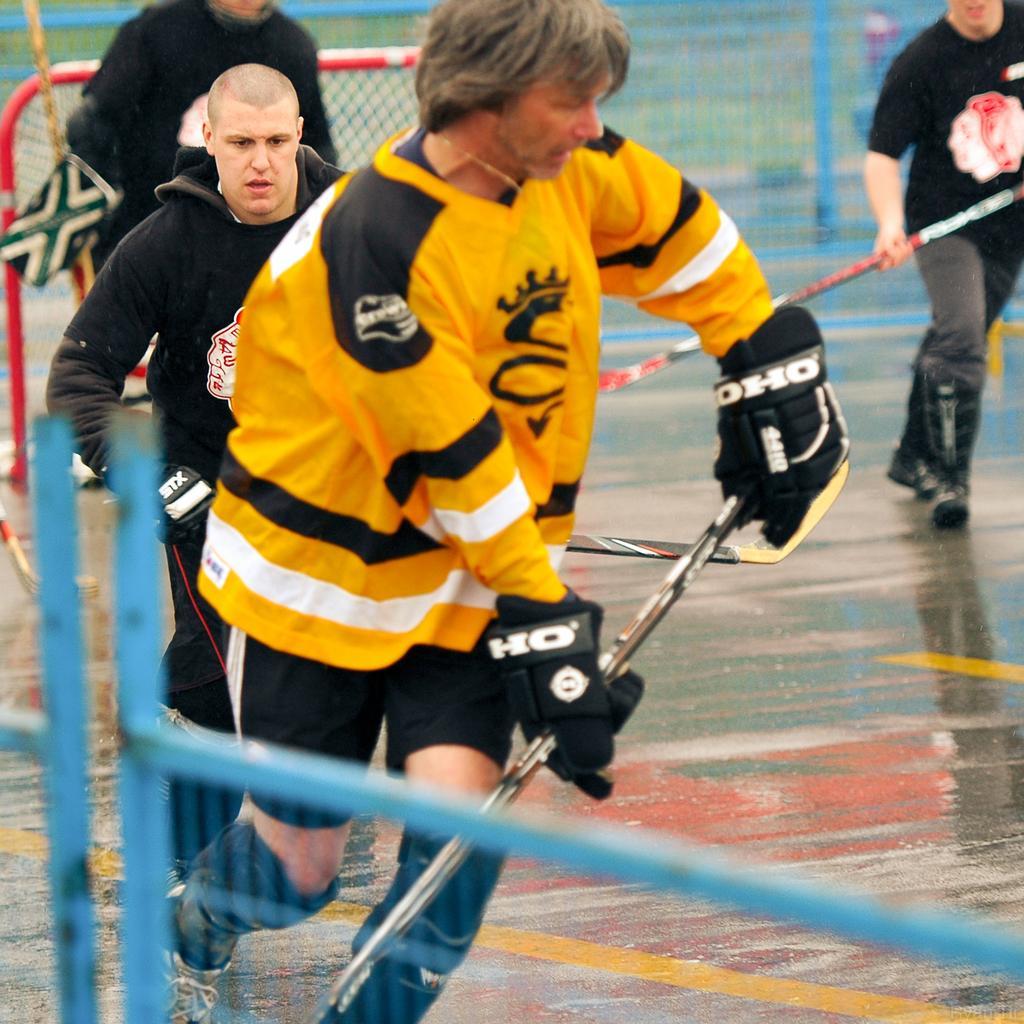How would you summarize this image in a sentence or two? In this picture there are group of people holding the bats and running. In the foreground there is a fence. At the back there is a fence. At the bottom there is grass and there is a floor. 